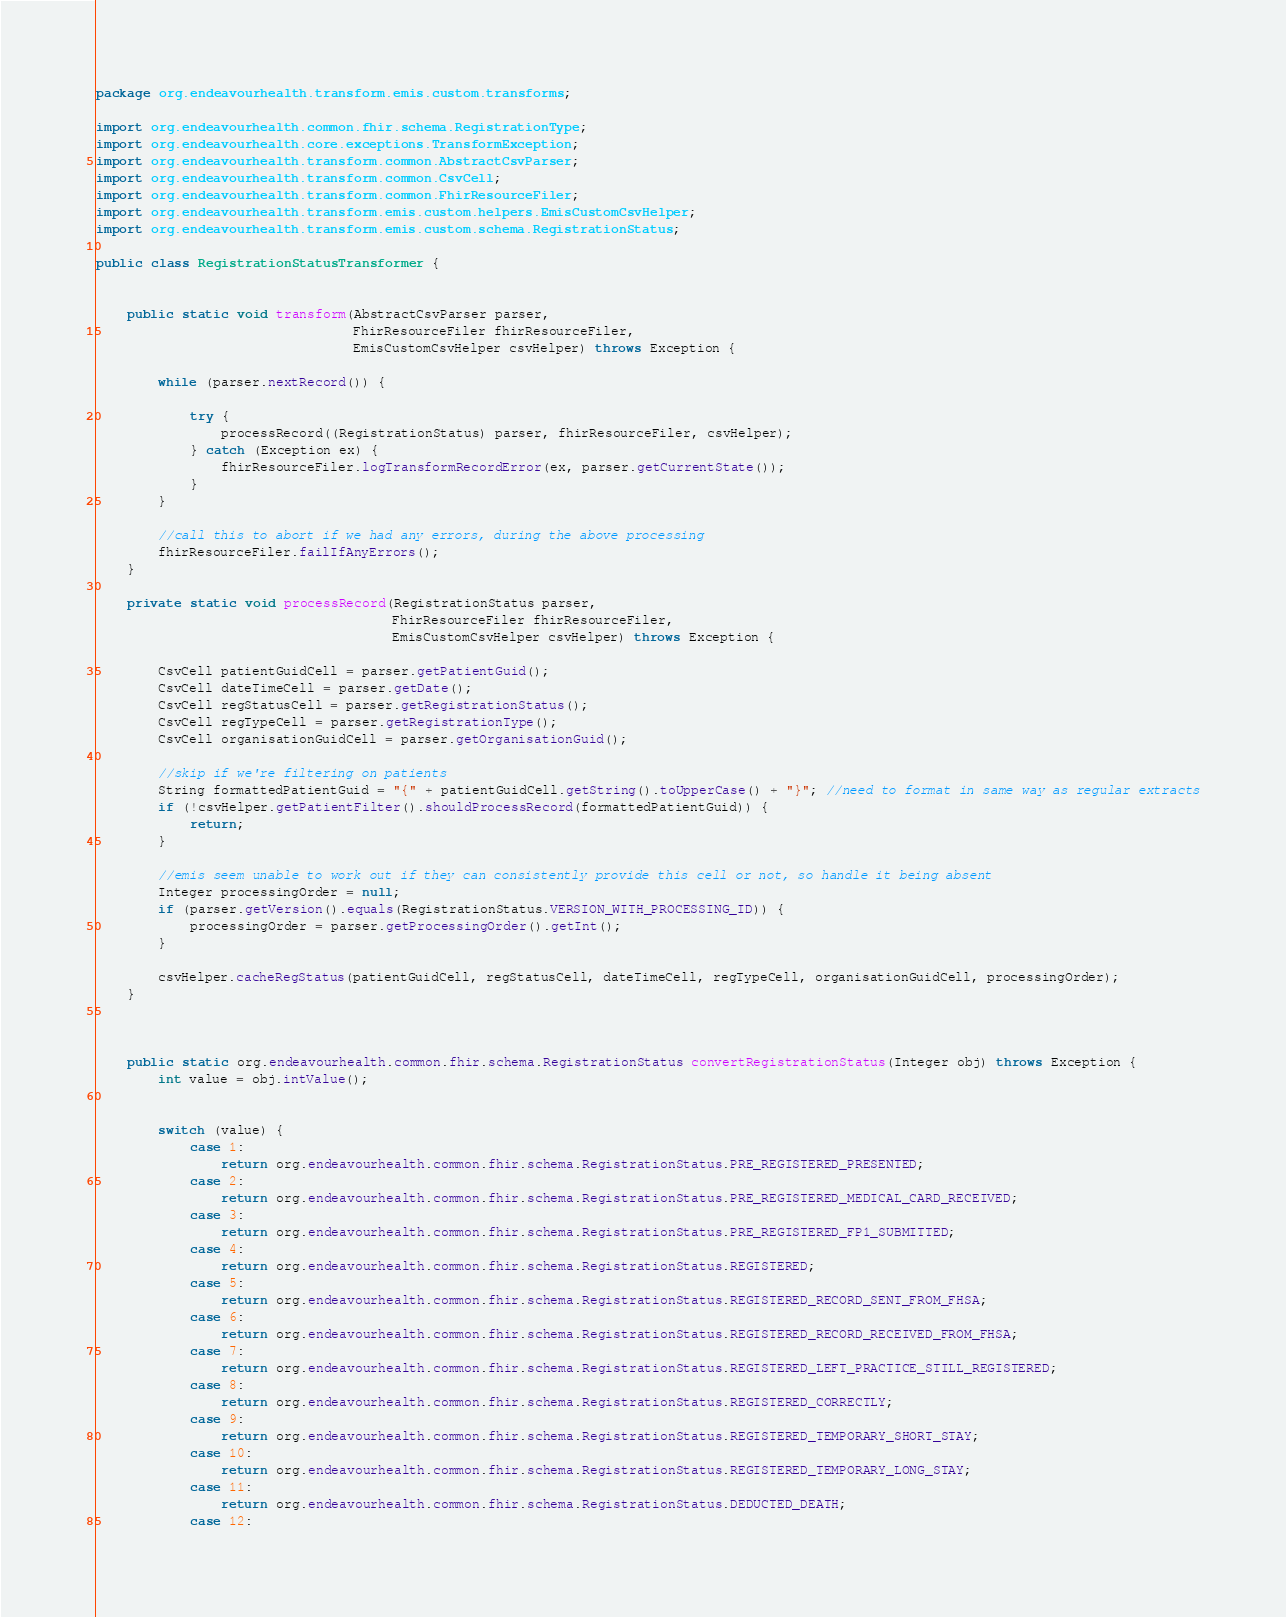<code> <loc_0><loc_0><loc_500><loc_500><_Java_>package org.endeavourhealth.transform.emis.custom.transforms;

import org.endeavourhealth.common.fhir.schema.RegistrationType;
import org.endeavourhealth.core.exceptions.TransformException;
import org.endeavourhealth.transform.common.AbstractCsvParser;
import org.endeavourhealth.transform.common.CsvCell;
import org.endeavourhealth.transform.common.FhirResourceFiler;
import org.endeavourhealth.transform.emis.custom.helpers.EmisCustomCsvHelper;
import org.endeavourhealth.transform.emis.custom.schema.RegistrationStatus;

public class RegistrationStatusTransformer {

    
    public static void transform(AbstractCsvParser parser,
                                 FhirResourceFiler fhirResourceFiler,
                                 EmisCustomCsvHelper csvHelper) throws Exception {

        while (parser.nextRecord()) {

            try {
                processRecord((RegistrationStatus) parser, fhirResourceFiler, csvHelper);
            } catch (Exception ex) {
                fhirResourceFiler.logTransformRecordError(ex, parser.getCurrentState());
            }
        }

        //call this to abort if we had any errors, during the above processing
        fhirResourceFiler.failIfAnyErrors();
    }

    private static void processRecord(RegistrationStatus parser,
                                      FhirResourceFiler fhirResourceFiler,
                                      EmisCustomCsvHelper csvHelper) throws Exception {

        CsvCell patientGuidCell = parser.getPatientGuid();
        CsvCell dateTimeCell = parser.getDate();
        CsvCell regStatusCell = parser.getRegistrationStatus();
        CsvCell regTypeCell = parser.getRegistrationType();
        CsvCell organisationGuidCell = parser.getOrganisationGuid();

        //skip if we're filtering on patients
        String formattedPatientGuid = "{" + patientGuidCell.getString().toUpperCase() + "}"; //need to format in same way as regular extracts
        if (!csvHelper.getPatientFilter().shouldProcessRecord(formattedPatientGuid)) {
            return;
        }

        //emis seem unable to work out if they can consistently provide this cell or not, so handle it being absent
        Integer processingOrder = null;
        if (parser.getVersion().equals(RegistrationStatus.VERSION_WITH_PROCESSING_ID)) {
            processingOrder = parser.getProcessingOrder().getInt();
        }

        csvHelper.cacheRegStatus(patientGuidCell, regStatusCell, dateTimeCell, regTypeCell, organisationGuidCell, processingOrder);
    }



    public static org.endeavourhealth.common.fhir.schema.RegistrationStatus convertRegistrationStatus(Integer obj) throws Exception {
        int value = obj.intValue();


        switch (value) {
            case 1:
                return org.endeavourhealth.common.fhir.schema.RegistrationStatus.PRE_REGISTERED_PRESENTED;
            case 2:
                return org.endeavourhealth.common.fhir.schema.RegistrationStatus.PRE_REGISTERED_MEDICAL_CARD_RECEIVED;
            case 3:
                return org.endeavourhealth.common.fhir.schema.RegistrationStatus.PRE_REGISTERED_FP1_SUBMITTED;
            case 4:
                return org.endeavourhealth.common.fhir.schema.RegistrationStatus.REGISTERED;
            case 5:
                return org.endeavourhealth.common.fhir.schema.RegistrationStatus.REGISTERED_RECORD_SENT_FROM_FHSA;
            case 6:
                return org.endeavourhealth.common.fhir.schema.RegistrationStatus.REGISTERED_RECORD_RECEIVED_FROM_FHSA;
            case 7:
                return org.endeavourhealth.common.fhir.schema.RegistrationStatus.REGISTERED_LEFT_PRACTICE_STILL_REGISTERED;
            case 8:
                return org.endeavourhealth.common.fhir.schema.RegistrationStatus.REGISTERED_CORRECTLY;
            case 9:
                return org.endeavourhealth.common.fhir.schema.RegistrationStatus.REGISTERED_TEMPORARY_SHORT_STAY;
            case 10:
                return org.endeavourhealth.common.fhir.schema.RegistrationStatus.REGISTERED_TEMPORARY_LONG_STAY;
            case 11:
                return org.endeavourhealth.common.fhir.schema.RegistrationStatus.DEDUCTED_DEATH;
            case 12:</code> 